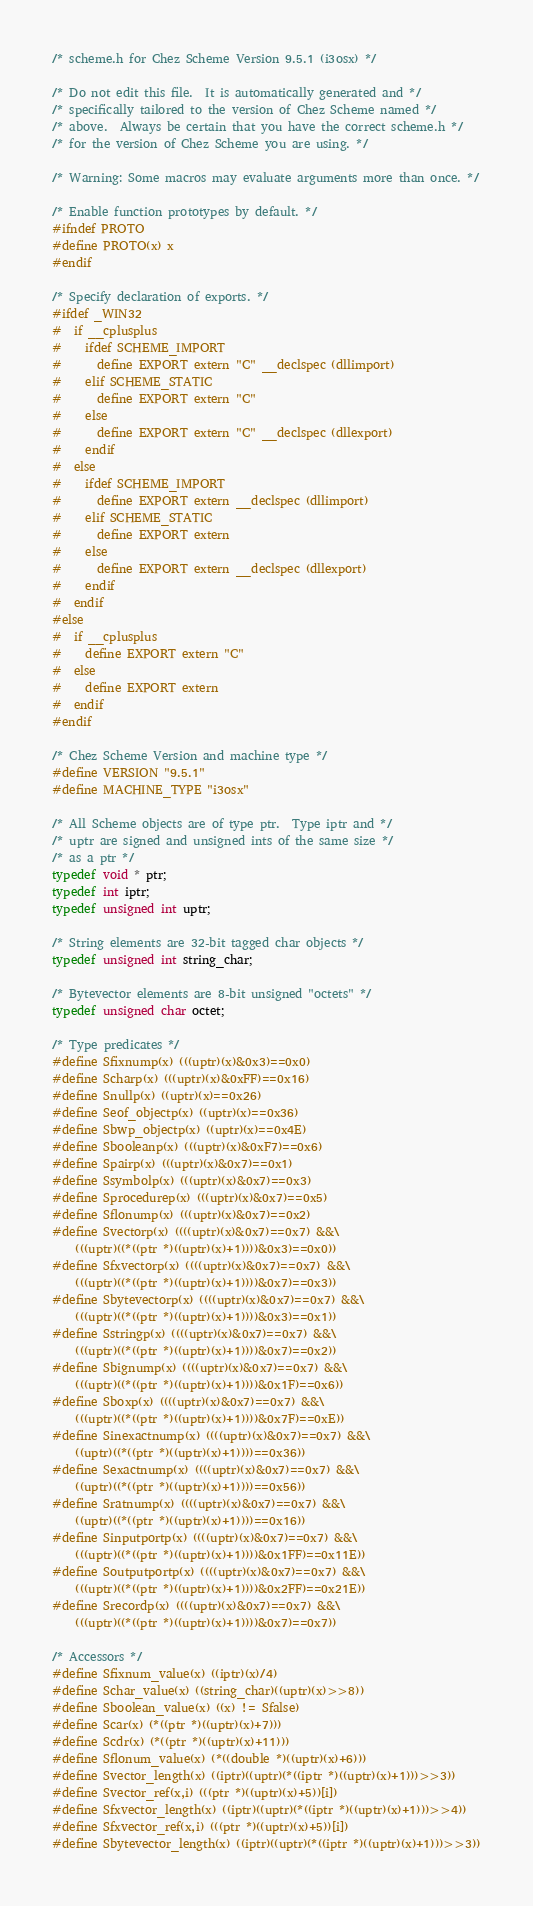<code> <loc_0><loc_0><loc_500><loc_500><_C_>/* scheme.h for Chez Scheme Version 9.5.1 (i3osx) */

/* Do not edit this file.  It is automatically generated and */
/* specifically tailored to the version of Chez Scheme named */
/* above.  Always be certain that you have the correct scheme.h */
/* for the version of Chez Scheme you are using. */

/* Warning: Some macros may evaluate arguments more than once. */

/* Enable function prototypes by default. */
#ifndef PROTO
#define PROTO(x) x
#endif

/* Specify declaration of exports. */
#ifdef _WIN32
#  if __cplusplus
#    ifdef SCHEME_IMPORT
#      define EXPORT extern "C" __declspec (dllimport)
#    elif SCHEME_STATIC
#      define EXPORT extern "C"
#    else
#      define EXPORT extern "C" __declspec (dllexport)
#    endif
#  else
#    ifdef SCHEME_IMPORT
#      define EXPORT extern __declspec (dllimport)
#    elif SCHEME_STATIC
#      define EXPORT extern
#    else
#      define EXPORT extern __declspec (dllexport)
#    endif
#  endif
#else
#  if __cplusplus
#    define EXPORT extern "C"
#  else
#    define EXPORT extern
#  endif
#endif

/* Chez Scheme Version and machine type */
#define VERSION "9.5.1"
#define MACHINE_TYPE "i3osx"

/* All Scheme objects are of type ptr.  Type iptr and */
/* uptr are signed and unsigned ints of the same size */
/* as a ptr */
typedef void * ptr;
typedef int iptr;
typedef unsigned int uptr;

/* String elements are 32-bit tagged char objects */
typedef unsigned int string_char;

/* Bytevector elements are 8-bit unsigned "octets" */
typedef unsigned char octet;

/* Type predicates */
#define Sfixnump(x) (((uptr)(x)&0x3)==0x0)
#define Scharp(x) (((uptr)(x)&0xFF)==0x16)
#define Snullp(x) ((uptr)(x)==0x26)
#define Seof_objectp(x) ((uptr)(x)==0x36)
#define Sbwp_objectp(x) ((uptr)(x)==0x4E)
#define Sbooleanp(x) (((uptr)(x)&0xF7)==0x6)
#define Spairp(x) (((uptr)(x)&0x7)==0x1)
#define Ssymbolp(x) (((uptr)(x)&0x7)==0x3)
#define Sprocedurep(x) (((uptr)(x)&0x7)==0x5)
#define Sflonump(x) (((uptr)(x)&0x7)==0x2)
#define Svectorp(x) ((((uptr)(x)&0x7)==0x7) &&\
    (((uptr)((*((ptr *)((uptr)(x)+1))))&0x3)==0x0))
#define Sfxvectorp(x) ((((uptr)(x)&0x7)==0x7) &&\
    (((uptr)((*((ptr *)((uptr)(x)+1))))&0x7)==0x3))
#define Sbytevectorp(x) ((((uptr)(x)&0x7)==0x7) &&\
    (((uptr)((*((ptr *)((uptr)(x)+1))))&0x3)==0x1))
#define Sstringp(x) ((((uptr)(x)&0x7)==0x7) &&\
    (((uptr)((*((ptr *)((uptr)(x)+1))))&0x7)==0x2))
#define Sbignump(x) ((((uptr)(x)&0x7)==0x7) &&\
    (((uptr)((*((ptr *)((uptr)(x)+1))))&0x1F)==0x6))
#define Sboxp(x) ((((uptr)(x)&0x7)==0x7) &&\
    (((uptr)((*((ptr *)((uptr)(x)+1))))&0x7F)==0xE))
#define Sinexactnump(x) ((((uptr)(x)&0x7)==0x7) &&\
    ((uptr)((*((ptr *)((uptr)(x)+1))))==0x36))
#define Sexactnump(x) ((((uptr)(x)&0x7)==0x7) &&\
    ((uptr)((*((ptr *)((uptr)(x)+1))))==0x56))
#define Sratnump(x) ((((uptr)(x)&0x7)==0x7) &&\
    ((uptr)((*((ptr *)((uptr)(x)+1))))==0x16))
#define Sinputportp(x) ((((uptr)(x)&0x7)==0x7) &&\
    (((uptr)((*((ptr *)((uptr)(x)+1))))&0x1FF)==0x11E))
#define Soutputportp(x) ((((uptr)(x)&0x7)==0x7) &&\
    (((uptr)((*((ptr *)((uptr)(x)+1))))&0x2FF)==0x21E))
#define Srecordp(x) ((((uptr)(x)&0x7)==0x7) &&\
    (((uptr)((*((ptr *)((uptr)(x)+1))))&0x7)==0x7))

/* Accessors */
#define Sfixnum_value(x) ((iptr)(x)/4)
#define Schar_value(x) ((string_char)((uptr)(x)>>8))
#define Sboolean_value(x) ((x) != Sfalse)
#define Scar(x) (*((ptr *)((uptr)(x)+7)))
#define Scdr(x) (*((ptr *)((uptr)(x)+11)))
#define Sflonum_value(x) (*((double *)((uptr)(x)+6)))
#define Svector_length(x) ((iptr)((uptr)(*((iptr *)((uptr)(x)+1)))>>3))
#define Svector_ref(x,i) (((ptr *)((uptr)(x)+5))[i])
#define Sfxvector_length(x) ((iptr)((uptr)(*((iptr *)((uptr)(x)+1)))>>4))
#define Sfxvector_ref(x,i) (((ptr *)((uptr)(x)+5))[i])
#define Sbytevector_length(x) ((iptr)((uptr)(*((iptr *)((uptr)(x)+1)))>>3))</code> 